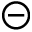<formula> <loc_0><loc_0><loc_500><loc_500>\circleddash</formula> 